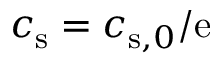Convert formula to latex. <formula><loc_0><loc_0><loc_500><loc_500>c _ { s } = c _ { s , 0 } / e</formula> 